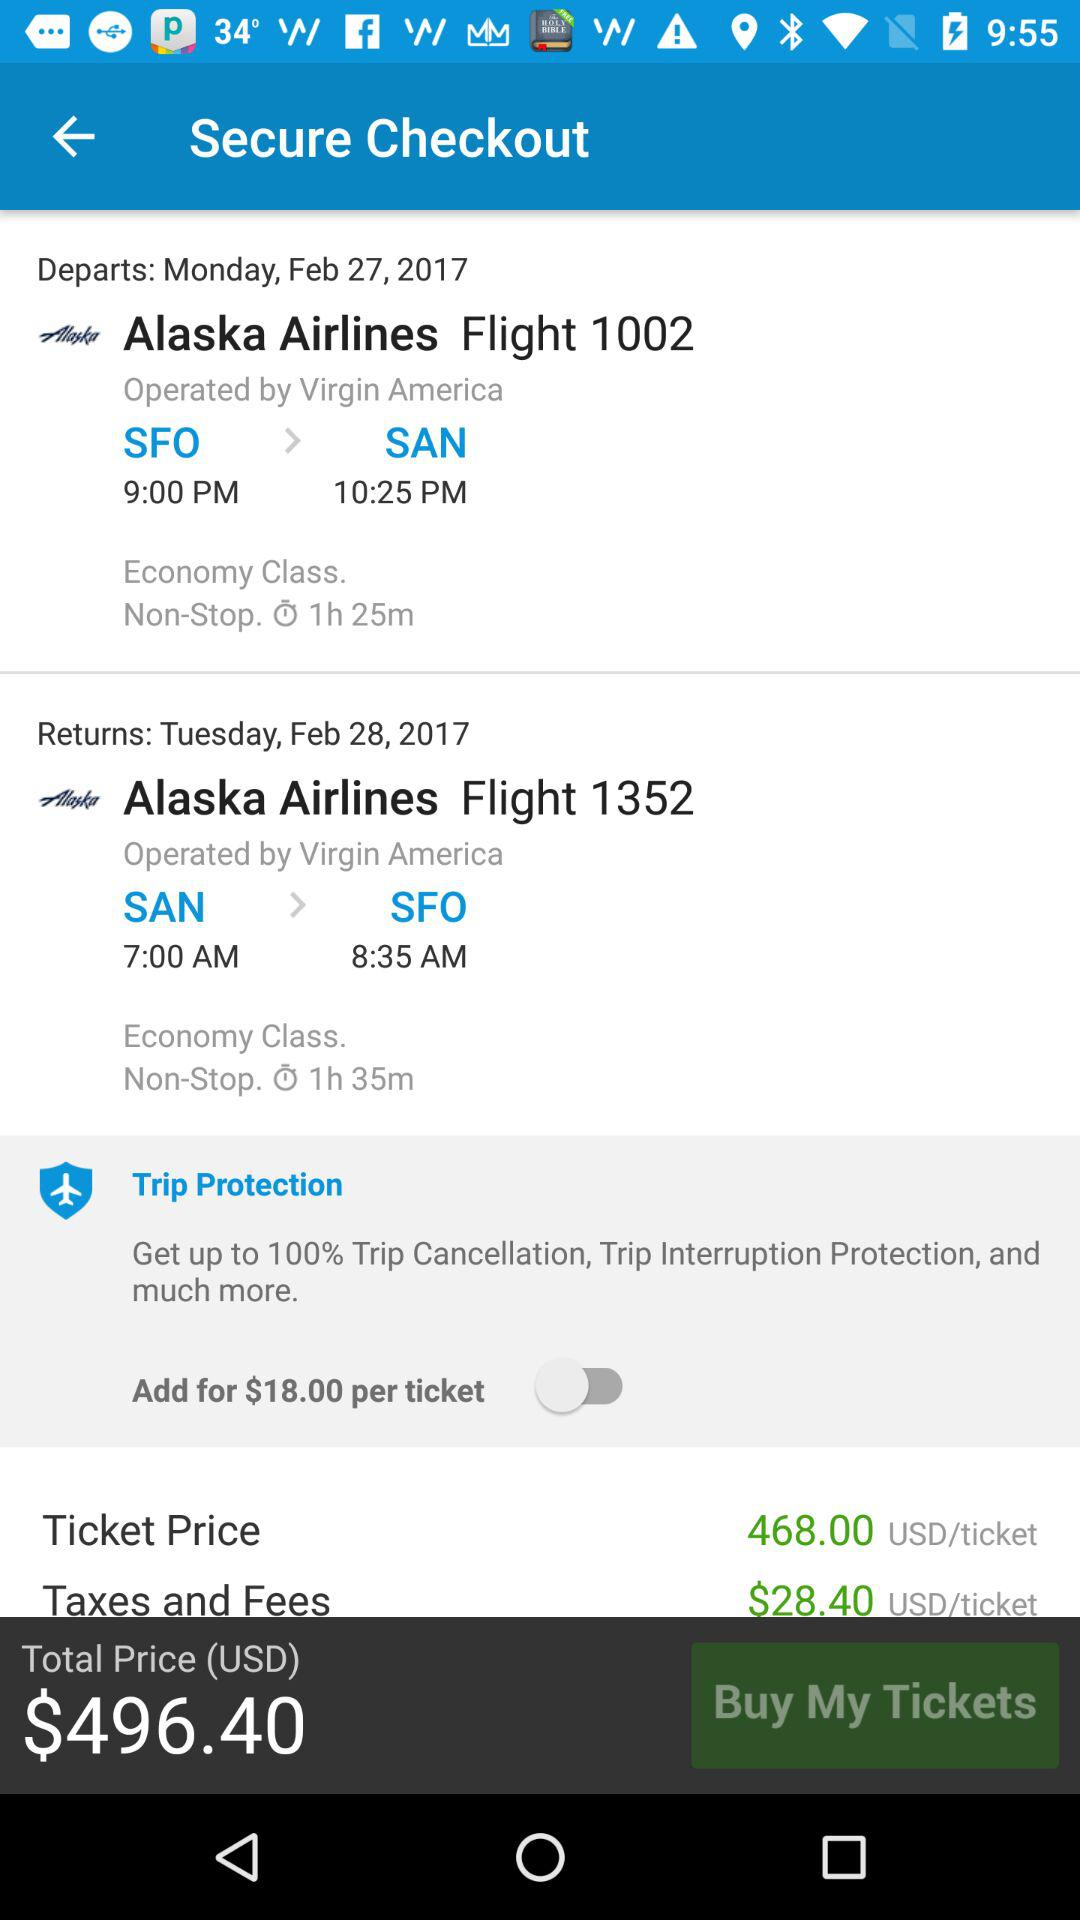How much are the taxes and fees? The taxes and fees are $28.40. 